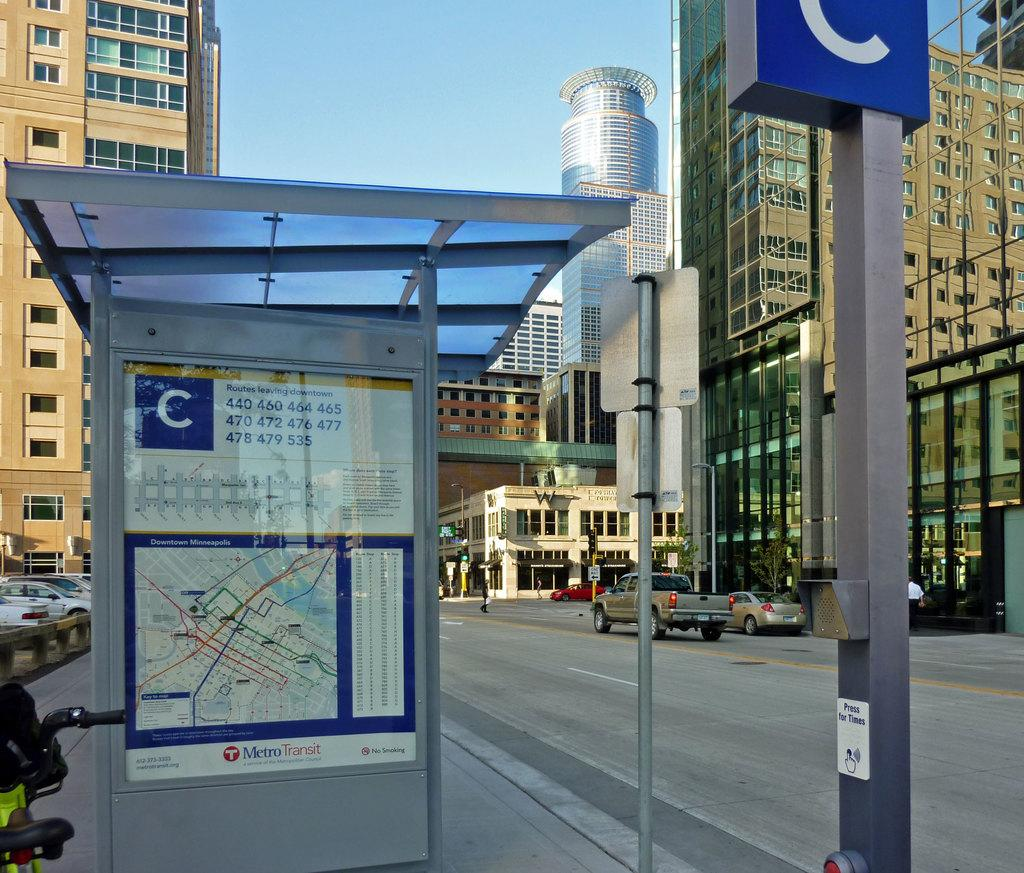What type of structures are visible in the image? There are buildings in the image. What feature do the buildings have? The buildings have windows. What else can be seen in the image besides the buildings? There is a pole with a board in the image, a shed, and vehicles on the road. What is the color of the sky in the image? The sky is blue and white in color. What type of invention is the farmer using in the image? There is no farmer or invention present in the image. How many wings can be seen on the vehicles in the image? The vehicles in the image do not have wings; they are likely cars or trucks. 